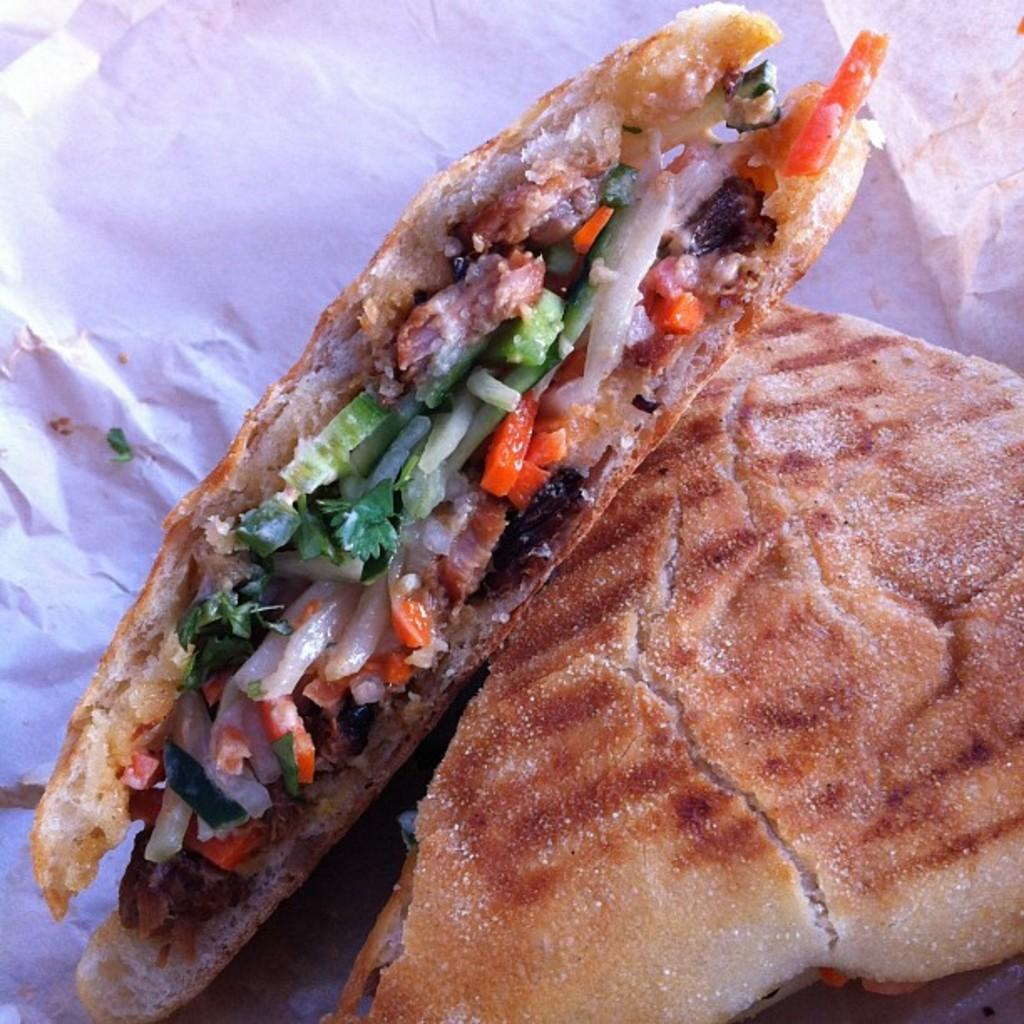What type of food can be seen in the image? There are sandwiches on a paper in the image. What is the aftermath of the sandwiches in the image? There is no aftermath of the sandwiches in the image, as it only shows the sandwiches on a paper. What flavor can be tasted in the sandwiches in the image? The image does not provide information about the flavor of the sandwiches. --- Facts: 1. There is a person holding a book in the image. 2. The person is sitting on a chair. 3. The book has a blue cover. 4. There is a table next to the chair. Absurd Topics: dance, ocean, parrot Conversation: What is the person in the image doing? The person is holding a book in the image. Where is the person sitting? The person is sitting on a chair. What color is the book's cover? The book has a blue cover. What is located next to the chair? There is a table next to the chair. Reasoning: Let's think step by step in order to produce the conversation. We start by identifying the main subject in the image, which is the person holding a book. Then, we provide a brief description of the person's position and the book's color. Finally, we mention the presence of a table next to the chair. Each question is designed to elicit a specific detail about the image that is known from the provided facts. Absurd Question/Answer: Can you see the person dancing with a parrot in the image? No, there is no person dancing with a parrot in the image. The image only shows a person sitting on a chair holding a book with a blue cover, and a table next to the chair. 